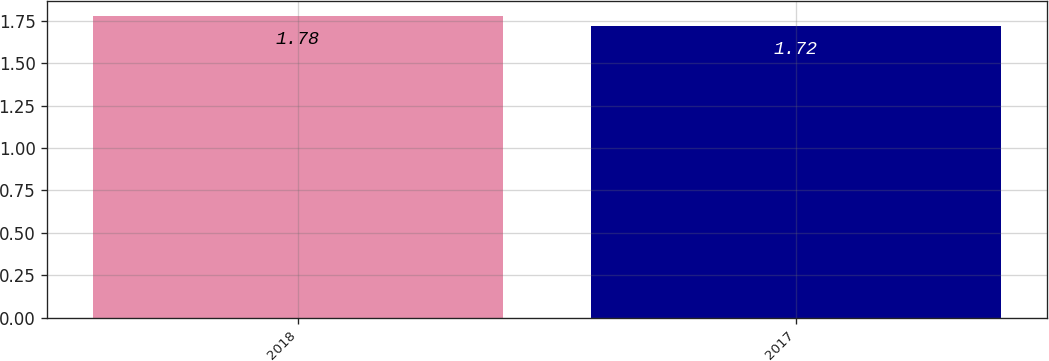Convert chart. <chart><loc_0><loc_0><loc_500><loc_500><bar_chart><fcel>2018<fcel>2017<nl><fcel>1.78<fcel>1.72<nl></chart> 